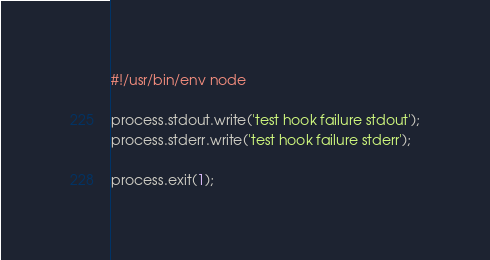<code> <loc_0><loc_0><loc_500><loc_500><_JavaScript_>#!/usr/bin/env node

process.stdout.write('test hook failure stdout');
process.stderr.write('test hook failure stderr');

process.exit(1);
</code> 